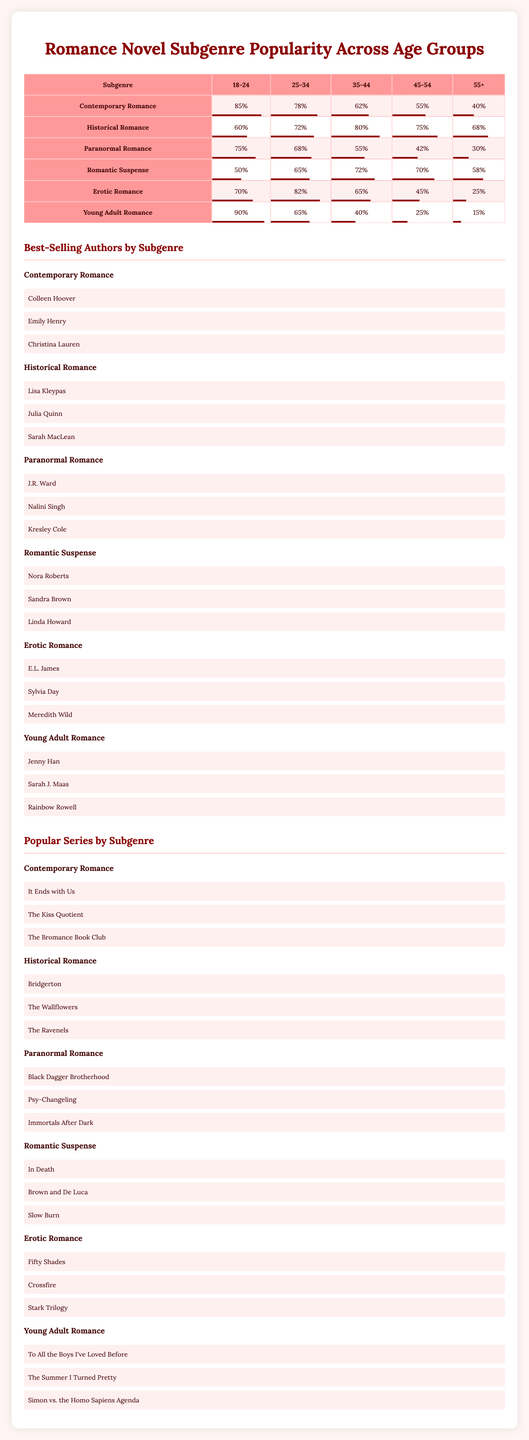What is the most popular romance subgenre among the 18-24 age group? The table shows that "Contemporary Romance" has the highest popularity score of 85% for the 18-24 age group.
Answer: Contemporary Romance Which subgenre is the least popular among those aged 55 and older? The table indicates that "Young Adult Romance" is the least popular with a score of 15% for the 55+ age group.
Answer: Young Adult Romance What is the popularity score of "Romantic Suspense" for the 35-44 age group? Referring to the table, "Romantic Suspense" has a popularity score of 72% for the 35-44 age group.
Answer: 72% Calculate the average popularity score of "Historical Romance" across all age groups. The scores for "Historical Romance" in each age group are 78, 72, 68, 65, and 82. Adding these gives 365. Dividing by 5, the average popularity score is 365/5 = 73.
Answer: 73 Is "Erotic Romance" more popular among the 25-34 age group than "Paranormal Romance"? The popularity score for "Erotic Romance" in the 25-34 age group is 72%, while "Paranormal Romance" is 68%. Since 72% is greater than 68%, the statement is true.
Answer: Yes Which romance subgenre has the highest popularity among those aged 45-54 and what is its score? Looking at the table, "Romantic Suspense" is the most popular at 70% for the 45-54 age group.
Answer: Romantic Suspense, 70% If you combine the popularity scores of "Contemporary Romance" and "Paranormal Romance" for the 35-44 age group, what is the total? For the 35-44 age group, "Contemporary Romance" has a score of 62% and "Paranormal Romance" has 55%. Adding these scores gives 62 + 55 = 117.
Answer: 117 Which age group shows the greatest decline in popularity for "Young Adult Romance" compared to the 18-24 age group? "Young Adult Romance" has a score of 90% for the 18-24 group and a score of 15% for those 55+. The decline from 90% to 15% is significant, resulting in a decline of 75%. Thus, the greatest decline is seen in the 55+ age group.
Answer: 55+ age group What is the popularity difference between "Historical Romance" and "Erotic Romance" for the 25-34 age group? The popularity score for "Historical Romance" is 72% and for "Erotic Romance" it is 75% in the 25-34 age group. The difference is 75 - 72 = 3%.
Answer: 3% 